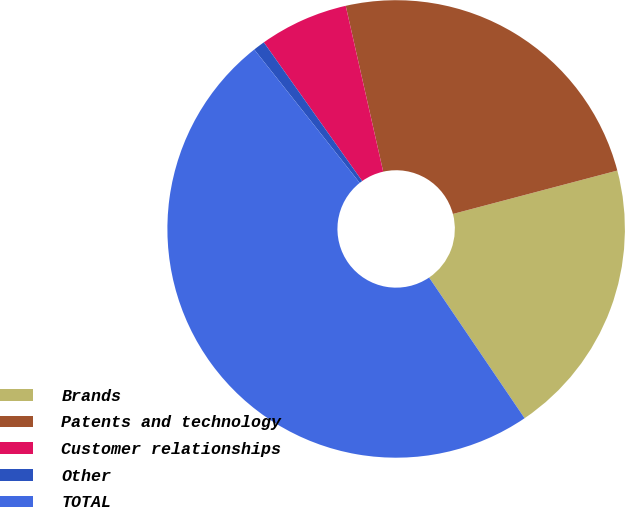<chart> <loc_0><loc_0><loc_500><loc_500><pie_chart><fcel>Brands<fcel>Patents and technology<fcel>Customer relationships<fcel>Other<fcel>TOTAL<nl><fcel>19.62%<fcel>24.43%<fcel>6.28%<fcel>0.83%<fcel>48.84%<nl></chart> 